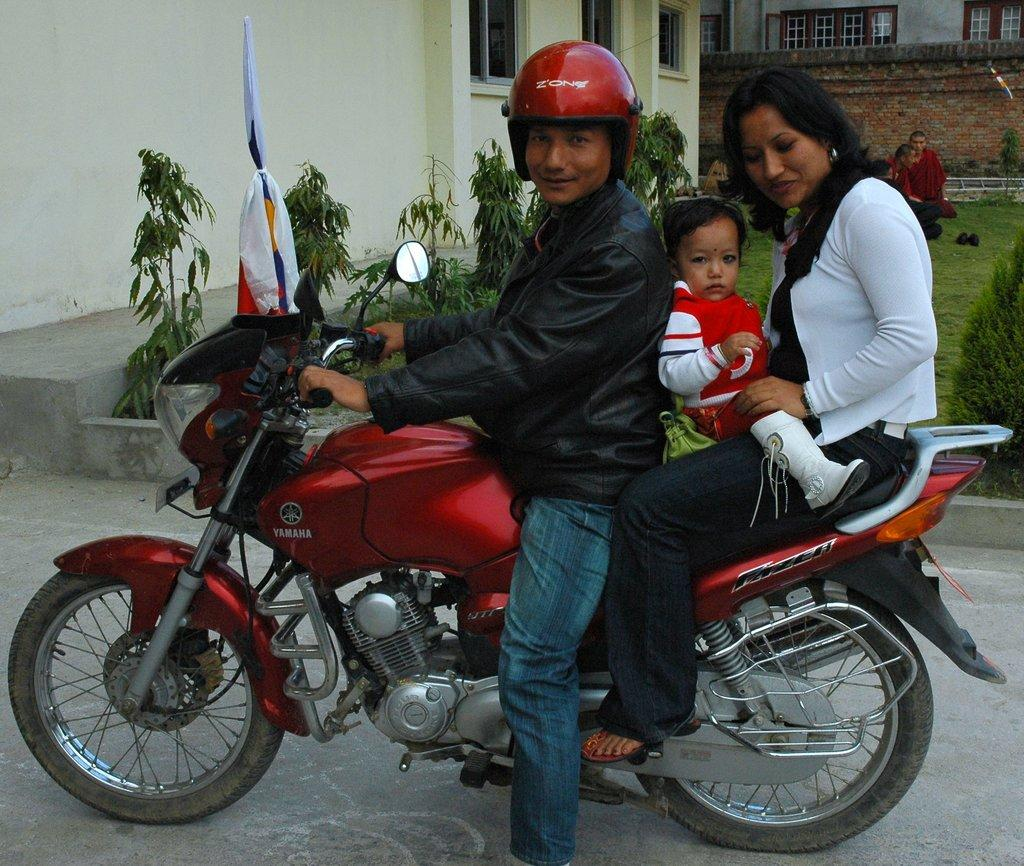What are the people on the bike doing? The people are sitting on a bike. Can you describe the position of the baby in the image? There is a baby between the people on the bike. What can be seen in the background of the image? There are plants and a building visible in the background. What type of fish can be seen swimming near the baby on the bike? There are no fish present in the image; it features people sitting on a bike with a baby between them and a background with plants and a building. 